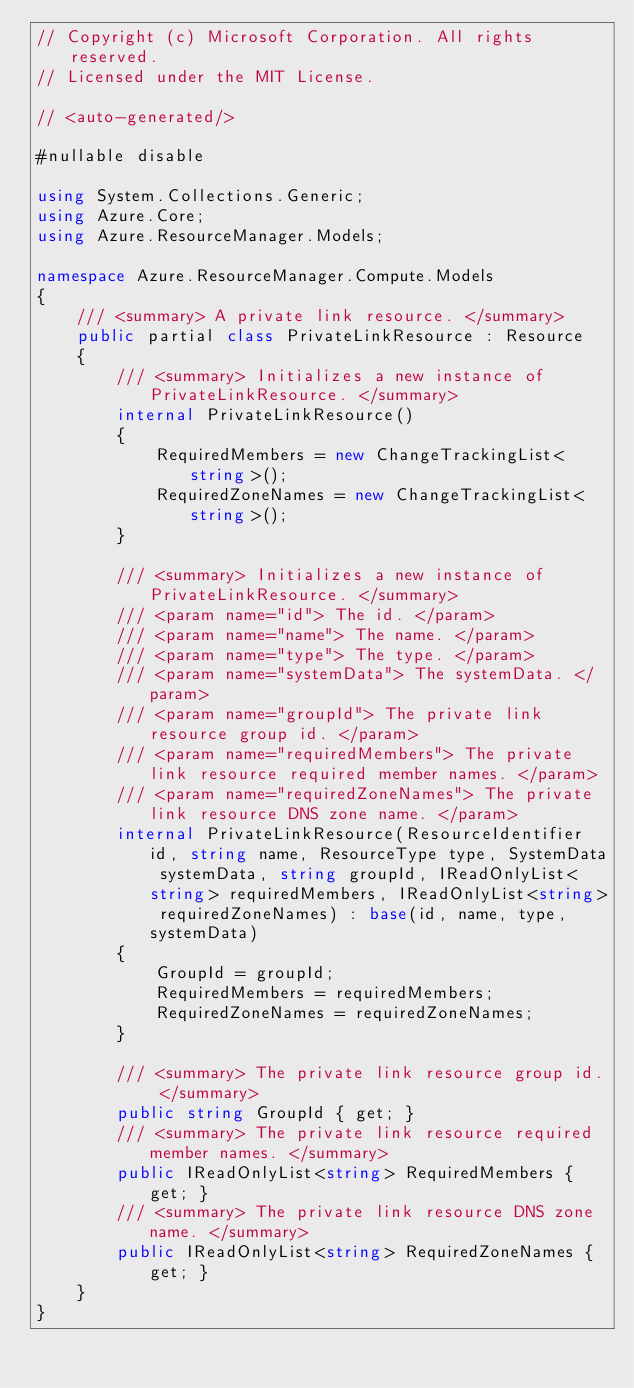Convert code to text. <code><loc_0><loc_0><loc_500><loc_500><_C#_>// Copyright (c) Microsoft Corporation. All rights reserved.
// Licensed under the MIT License.

// <auto-generated/>

#nullable disable

using System.Collections.Generic;
using Azure.Core;
using Azure.ResourceManager.Models;

namespace Azure.ResourceManager.Compute.Models
{
    /// <summary> A private link resource. </summary>
    public partial class PrivateLinkResource : Resource
    {
        /// <summary> Initializes a new instance of PrivateLinkResource. </summary>
        internal PrivateLinkResource()
        {
            RequiredMembers = new ChangeTrackingList<string>();
            RequiredZoneNames = new ChangeTrackingList<string>();
        }

        /// <summary> Initializes a new instance of PrivateLinkResource. </summary>
        /// <param name="id"> The id. </param>
        /// <param name="name"> The name. </param>
        /// <param name="type"> The type. </param>
        /// <param name="systemData"> The systemData. </param>
        /// <param name="groupId"> The private link resource group id. </param>
        /// <param name="requiredMembers"> The private link resource required member names. </param>
        /// <param name="requiredZoneNames"> The private link resource DNS zone name. </param>
        internal PrivateLinkResource(ResourceIdentifier id, string name, ResourceType type, SystemData systemData, string groupId, IReadOnlyList<string> requiredMembers, IReadOnlyList<string> requiredZoneNames) : base(id, name, type, systemData)
        {
            GroupId = groupId;
            RequiredMembers = requiredMembers;
            RequiredZoneNames = requiredZoneNames;
        }

        /// <summary> The private link resource group id. </summary>
        public string GroupId { get; }
        /// <summary> The private link resource required member names. </summary>
        public IReadOnlyList<string> RequiredMembers { get; }
        /// <summary> The private link resource DNS zone name. </summary>
        public IReadOnlyList<string> RequiredZoneNames { get; }
    }
}
</code> 